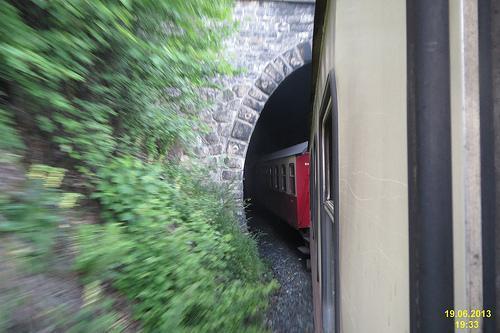How many types of plant?
Give a very brief answer. 1. 